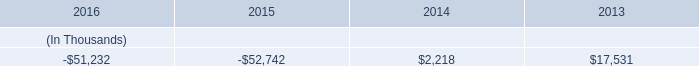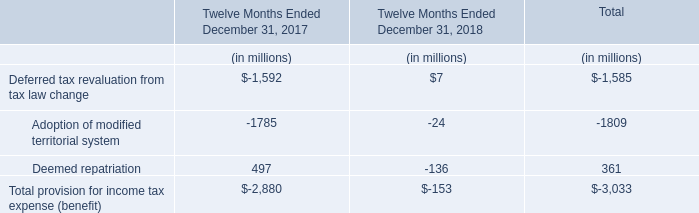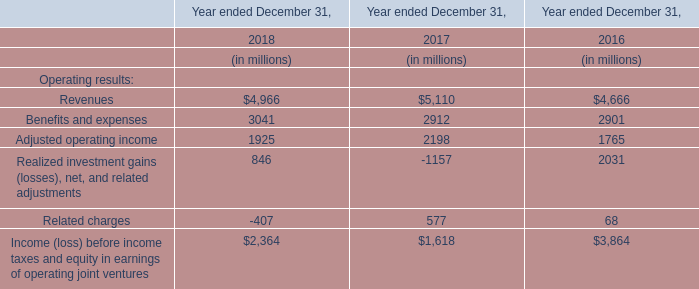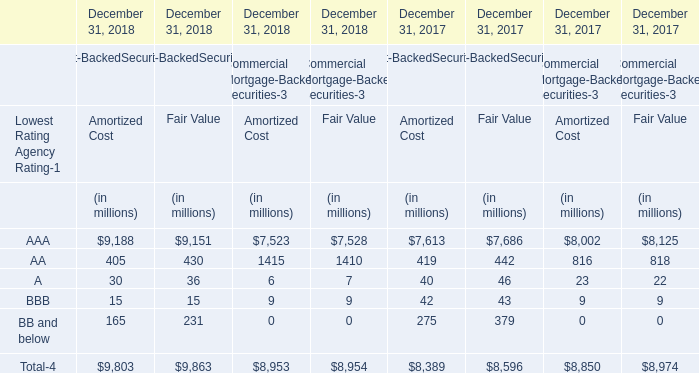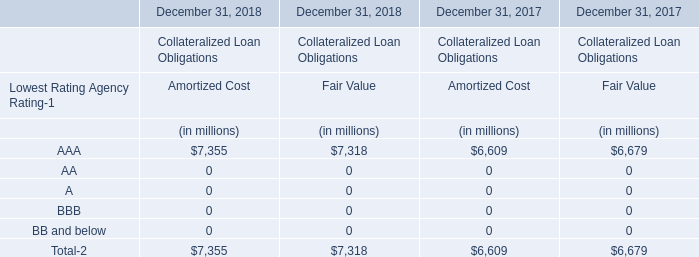If AAA for Fair Value develops with the same increasing rate in 2018, what will it reach in 2019? (in million) 
Computations: (7318 * (1 + ((7318 - 6679) / 6679)))
Answer: 8018.13505. 